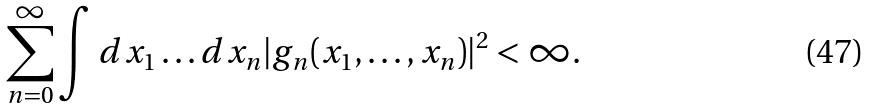Convert formula to latex. <formula><loc_0><loc_0><loc_500><loc_500>\sum _ { n = 0 } ^ { \infty } \int d x _ { 1 } \dots d x _ { n } | g _ { n } ( x _ { 1 } , \dots , x _ { n } ) | ^ { 2 } < \infty .</formula> 